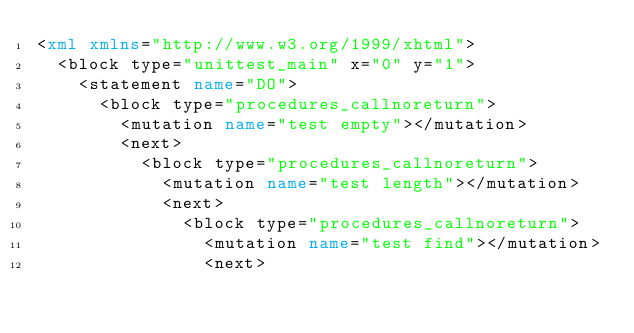Convert code to text. <code><loc_0><loc_0><loc_500><loc_500><_XML_><xml xmlns="http://www.w3.org/1999/xhtml">
  <block type="unittest_main" x="0" y="1">
    <statement name="DO">
      <block type="procedures_callnoreturn">
        <mutation name="test empty"></mutation>
        <next>
          <block type="procedures_callnoreturn">
            <mutation name="test length"></mutation>
            <next>
              <block type="procedures_callnoreturn">
                <mutation name="test find"></mutation>
                <next></code> 